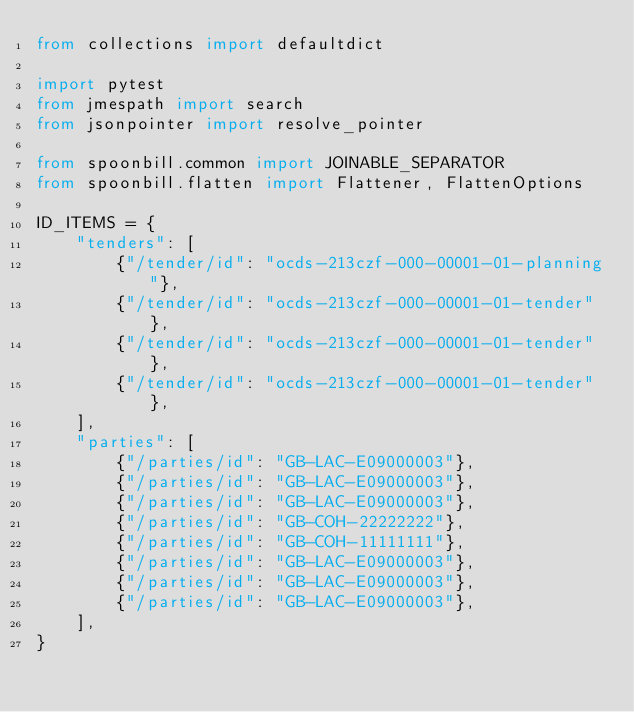Convert code to text. <code><loc_0><loc_0><loc_500><loc_500><_Python_>from collections import defaultdict

import pytest
from jmespath import search
from jsonpointer import resolve_pointer

from spoonbill.common import JOINABLE_SEPARATOR
from spoonbill.flatten import Flattener, FlattenOptions

ID_ITEMS = {
    "tenders": [
        {"/tender/id": "ocds-213czf-000-00001-01-planning"},
        {"/tender/id": "ocds-213czf-000-00001-01-tender"},
        {"/tender/id": "ocds-213czf-000-00001-01-tender"},
        {"/tender/id": "ocds-213czf-000-00001-01-tender"},
    ],
    "parties": [
        {"/parties/id": "GB-LAC-E09000003"},
        {"/parties/id": "GB-LAC-E09000003"},
        {"/parties/id": "GB-LAC-E09000003"},
        {"/parties/id": "GB-COH-22222222"},
        {"/parties/id": "GB-COH-11111111"},
        {"/parties/id": "GB-LAC-E09000003"},
        {"/parties/id": "GB-LAC-E09000003"},
        {"/parties/id": "GB-LAC-E09000003"},
    ],
}

</code> 